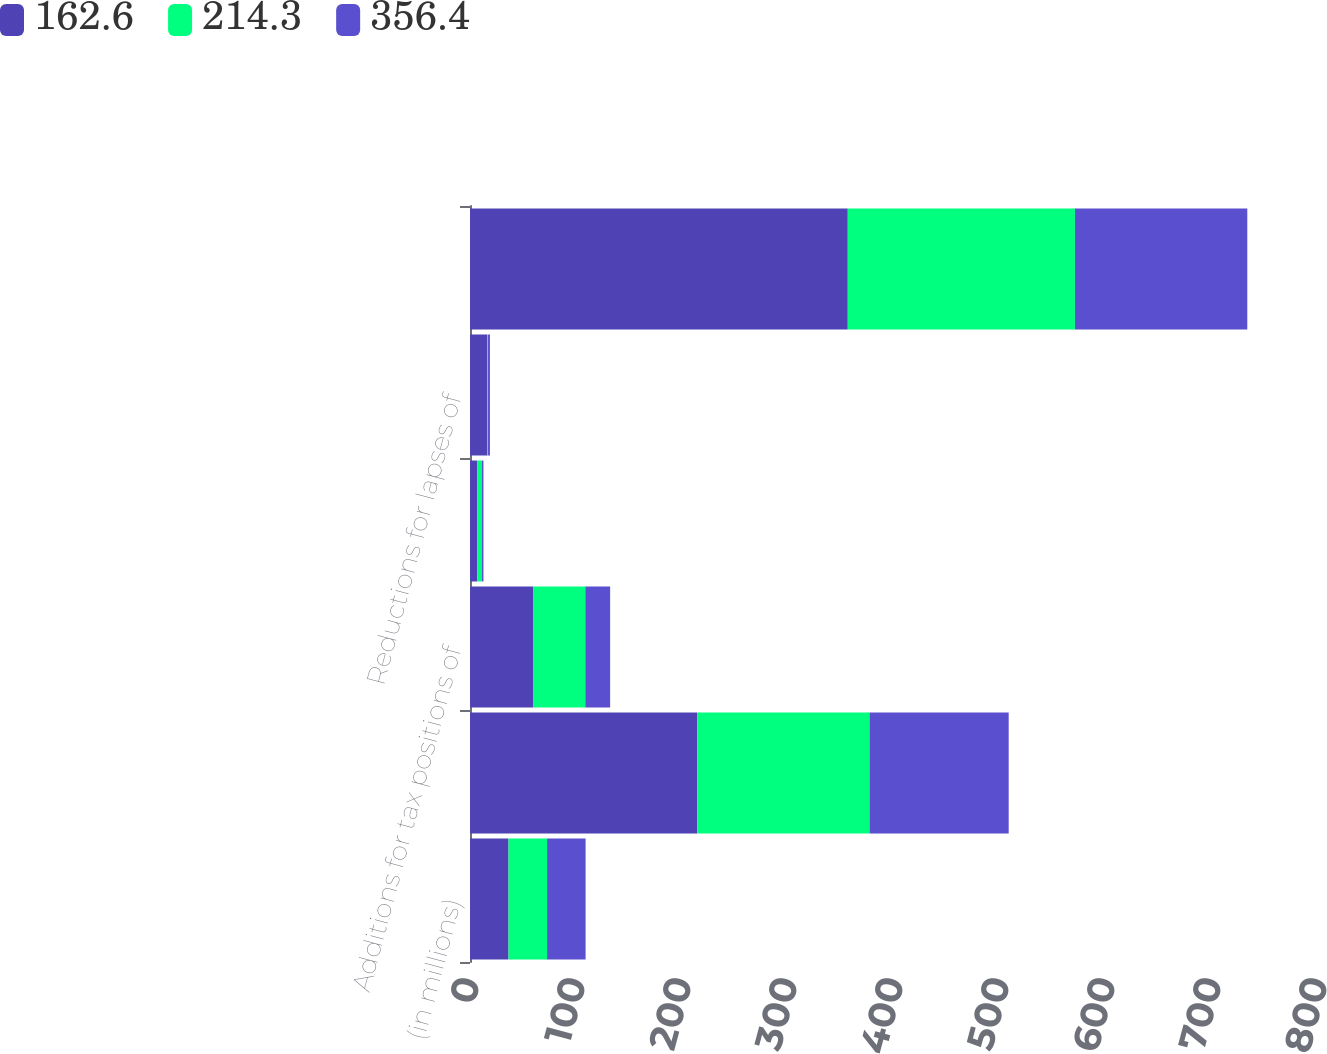Convert chart. <chart><loc_0><loc_0><loc_500><loc_500><stacked_bar_chart><ecel><fcel>(in millions)<fcel>Beginning balance of<fcel>Additions for tax positions of<fcel>Reductions for tax positions<fcel>Reductions for lapses of<fcel>Ending balance of unrecognized<nl><fcel>162.6<fcel>36.35<fcel>214.3<fcel>59.5<fcel>7<fcel>16.4<fcel>356.4<nl><fcel>214.3<fcel>36.35<fcel>162.6<fcel>49.3<fcel>4.3<fcel>0.6<fcel>214.3<nl><fcel>356.4<fcel>36.35<fcel>131.3<fcel>23.4<fcel>1.4<fcel>1.8<fcel>162.6<nl></chart> 